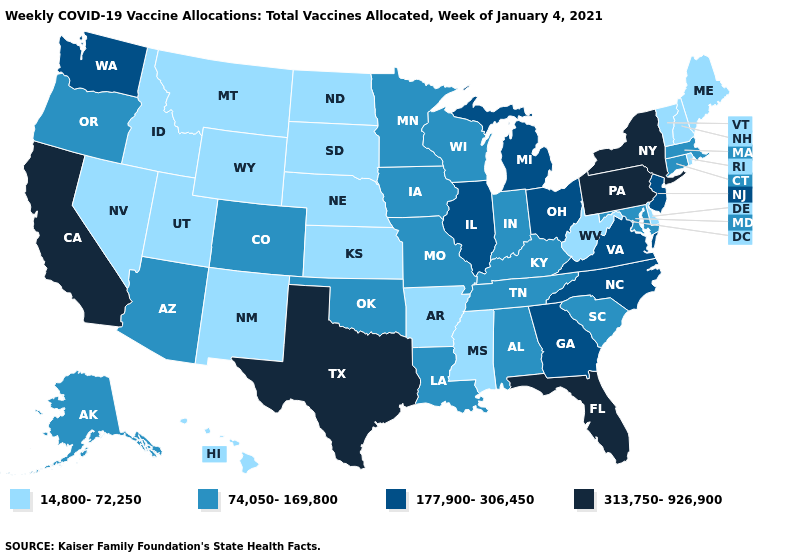Does Oklahoma have the highest value in the USA?
Short answer required. No. What is the value of New Mexico?
Concise answer only. 14,800-72,250. What is the highest value in the USA?
Answer briefly. 313,750-926,900. What is the value of Arizona?
Concise answer only. 74,050-169,800. Which states have the lowest value in the South?
Short answer required. Arkansas, Delaware, Mississippi, West Virginia. Name the states that have a value in the range 177,900-306,450?
Answer briefly. Georgia, Illinois, Michigan, New Jersey, North Carolina, Ohio, Virginia, Washington. Among the states that border Mississippi , which have the lowest value?
Give a very brief answer. Arkansas. Does South Carolina have a lower value than New Hampshire?
Short answer required. No. What is the value of Indiana?
Quick response, please. 74,050-169,800. Name the states that have a value in the range 74,050-169,800?
Keep it brief. Alabama, Alaska, Arizona, Colorado, Connecticut, Indiana, Iowa, Kentucky, Louisiana, Maryland, Massachusetts, Minnesota, Missouri, Oklahoma, Oregon, South Carolina, Tennessee, Wisconsin. What is the value of South Dakota?
Keep it brief. 14,800-72,250. Does Wyoming have the lowest value in the West?
Quick response, please. Yes. Is the legend a continuous bar?
Be succinct. No. Name the states that have a value in the range 313,750-926,900?
Short answer required. California, Florida, New York, Pennsylvania, Texas. 